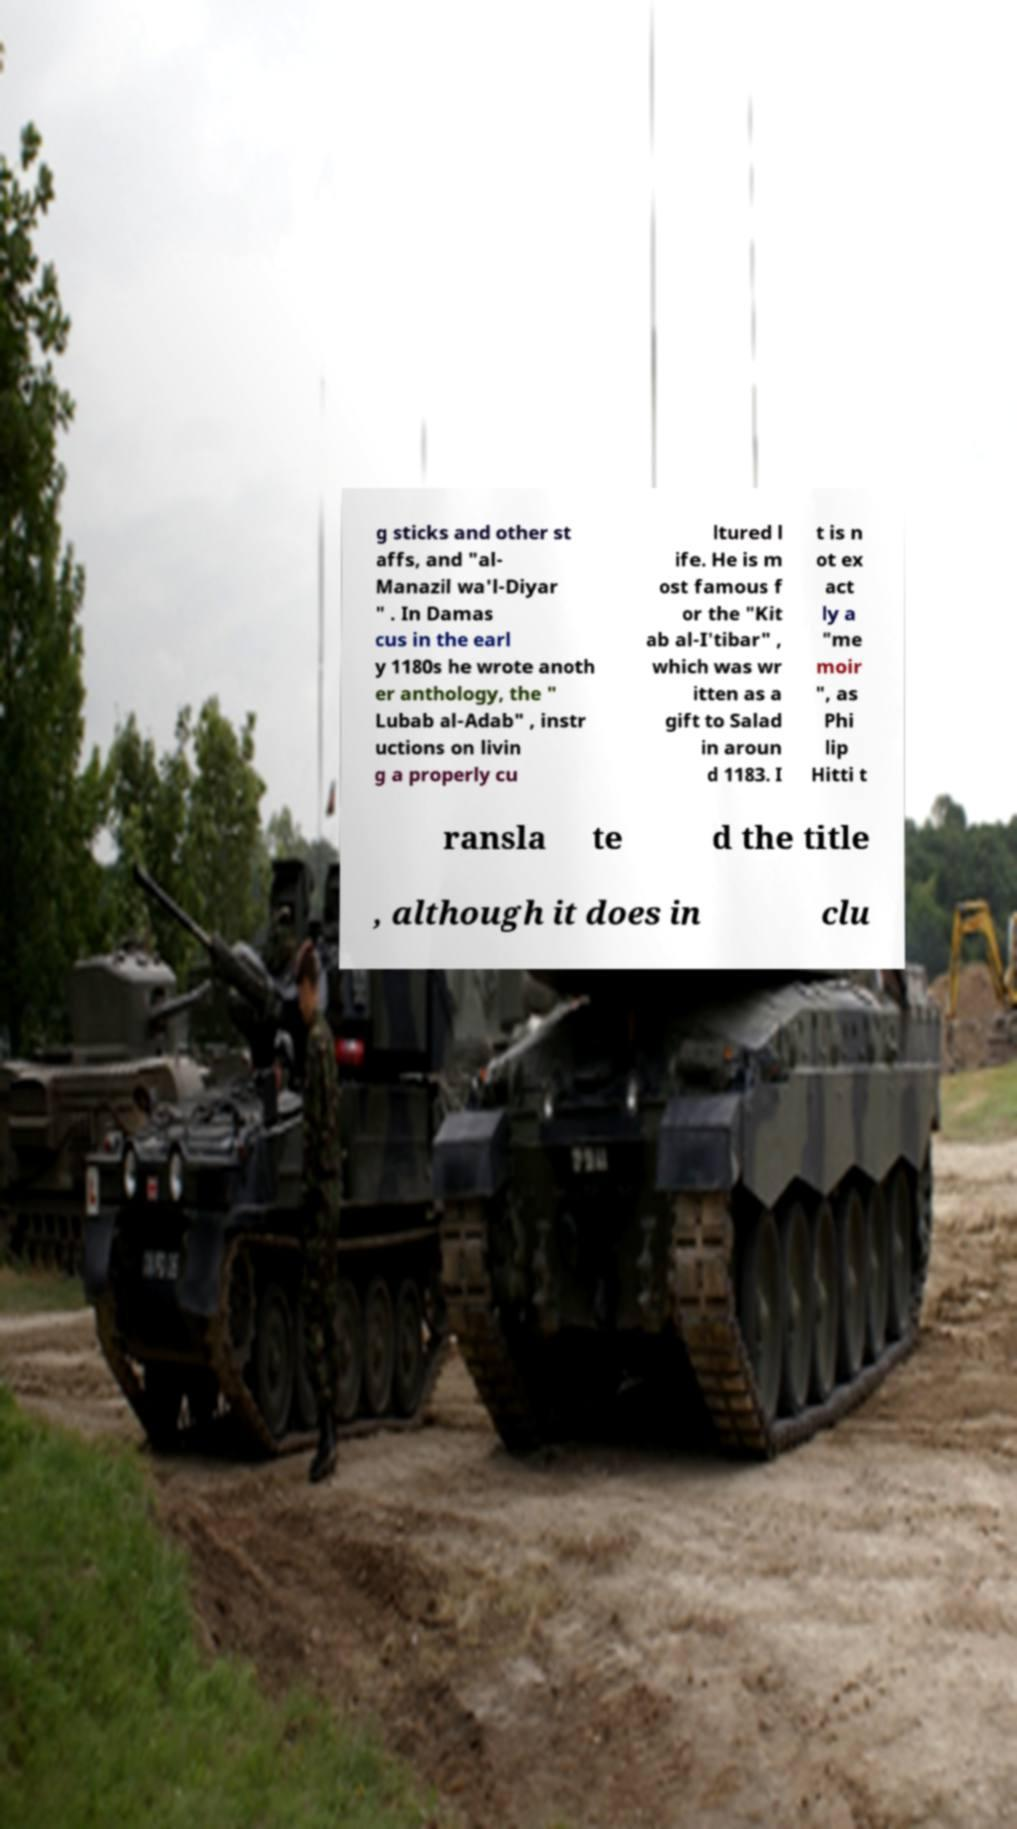Please identify and transcribe the text found in this image. g sticks and other st affs, and "al- Manazil wa'l-Diyar " . In Damas cus in the earl y 1180s he wrote anoth er anthology, the " Lubab al-Adab" , instr uctions on livin g a properly cu ltured l ife. He is m ost famous f or the "Kit ab al-I'tibar" , which was wr itten as a gift to Salad in aroun d 1183. I t is n ot ex act ly a "me moir ", as Phi lip Hitti t ransla te d the title , although it does in clu 